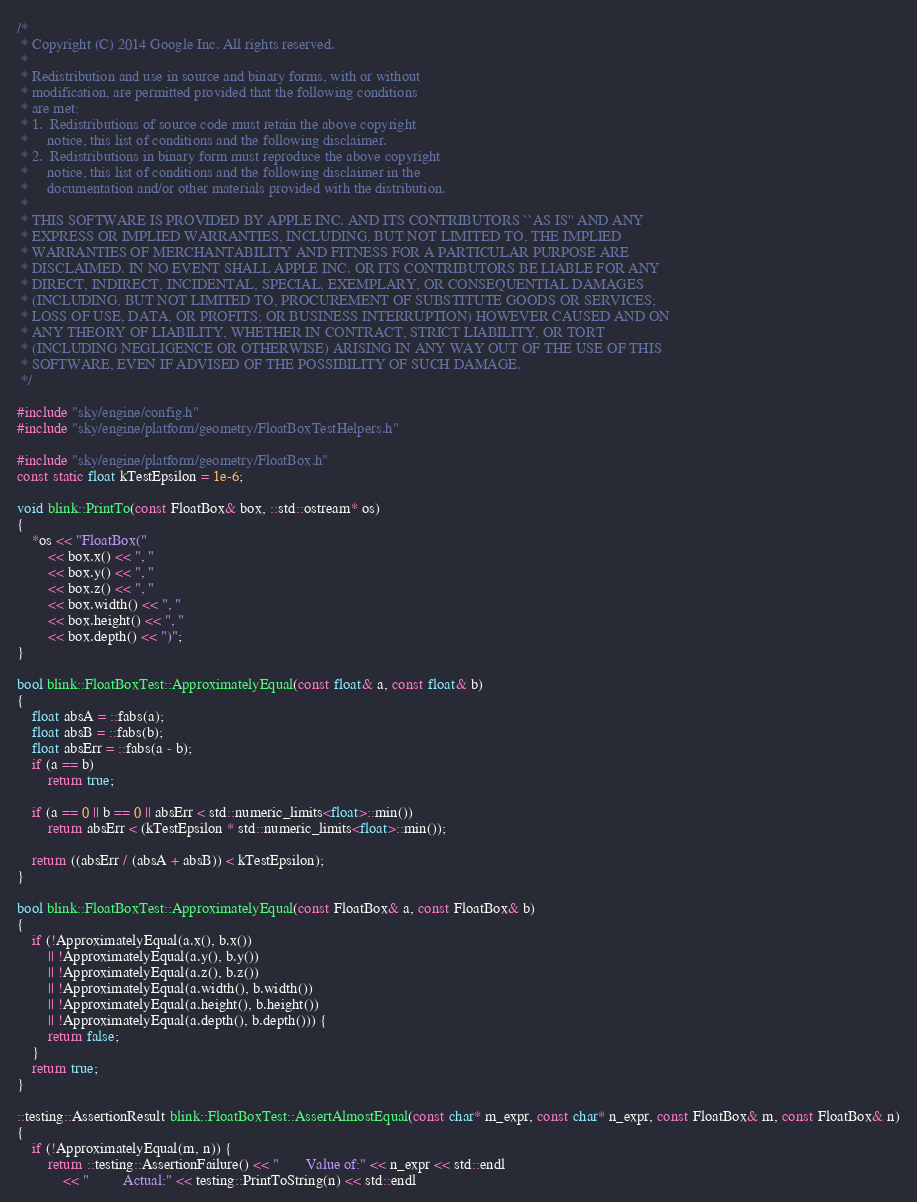<code> <loc_0><loc_0><loc_500><loc_500><_C++_>/*
 * Copyright (C) 2014 Google Inc. All rights reserved.
 *
 * Redistribution and use in source and binary forms, with or without
 * modification, are permitted provided that the following conditions
 * are met:
 * 1.  Redistributions of source code must retain the above copyright
 *     notice, this list of conditions and the following disclaimer.
 * 2.  Redistributions in binary form must reproduce the above copyright
 *     notice, this list of conditions and the following disclaimer in the
 *     documentation and/or other materials provided with the distribution.
 *
 * THIS SOFTWARE IS PROVIDED BY APPLE INC. AND ITS CONTRIBUTORS ``AS IS'' AND ANY
 * EXPRESS OR IMPLIED WARRANTIES, INCLUDING, BUT NOT LIMITED TO, THE IMPLIED
 * WARRANTIES OF MERCHANTABILITY AND FITNESS FOR A PARTICULAR PURPOSE ARE
 * DISCLAIMED. IN NO EVENT SHALL APPLE INC. OR ITS CONTRIBUTORS BE LIABLE FOR ANY
 * DIRECT, INDIRECT, INCIDENTAL, SPECIAL, EXEMPLARY, OR CONSEQUENTIAL DAMAGES
 * (INCLUDING, BUT NOT LIMITED TO, PROCUREMENT OF SUBSTITUTE GOODS OR SERVICES;
 * LOSS OF USE, DATA, OR PROFITS; OR BUSINESS INTERRUPTION) HOWEVER CAUSED AND ON
 * ANY THEORY OF LIABILITY, WHETHER IN CONTRACT, STRICT LIABILITY, OR TORT
 * (INCLUDING NEGLIGENCE OR OTHERWISE) ARISING IN ANY WAY OUT OF THE USE OF THIS
 * SOFTWARE, EVEN IF ADVISED OF THE POSSIBILITY OF SUCH DAMAGE.
 */

#include "sky/engine/config.h"
#include "sky/engine/platform/geometry/FloatBoxTestHelpers.h"

#include "sky/engine/platform/geometry/FloatBox.h"
const static float kTestEpsilon = 1e-6;

void blink::PrintTo(const FloatBox& box, ::std::ostream* os)
{
    *os << "FloatBox("
        << box.x() << ", "
        << box.y() << ", "
        << box.z() << ", "
        << box.width() << ", "
        << box.height() << ", "
        << box.depth() << ")";
}

bool blink::FloatBoxTest::ApproximatelyEqual(const float& a, const float& b)
{
    float absA = ::fabs(a);
    float absB = ::fabs(b);
    float absErr = ::fabs(a - b);
    if (a == b)
        return true;

    if (a == 0 || b == 0 || absErr < std::numeric_limits<float>::min())
        return absErr < (kTestEpsilon * std::numeric_limits<float>::min());

    return ((absErr / (absA + absB)) < kTestEpsilon);
}

bool blink::FloatBoxTest::ApproximatelyEqual(const FloatBox& a, const FloatBox& b)
{
    if (!ApproximatelyEqual(a.x(), b.x())
        || !ApproximatelyEqual(a.y(), b.y())
        || !ApproximatelyEqual(a.z(), b.z())
        || !ApproximatelyEqual(a.width(), b.width())
        || !ApproximatelyEqual(a.height(), b.height())
        || !ApproximatelyEqual(a.depth(), b.depth())) {
        return false;
    }
    return true;
}

::testing::AssertionResult blink::FloatBoxTest::AssertAlmostEqual(const char* m_expr, const char* n_expr, const FloatBox& m, const FloatBox& n)
{
    if (!ApproximatelyEqual(m, n)) {
        return ::testing::AssertionFailure() << "       Value of:" << n_expr << std::endl
            << "         Actual:" << testing::PrintToString(n) << std::endl</code> 